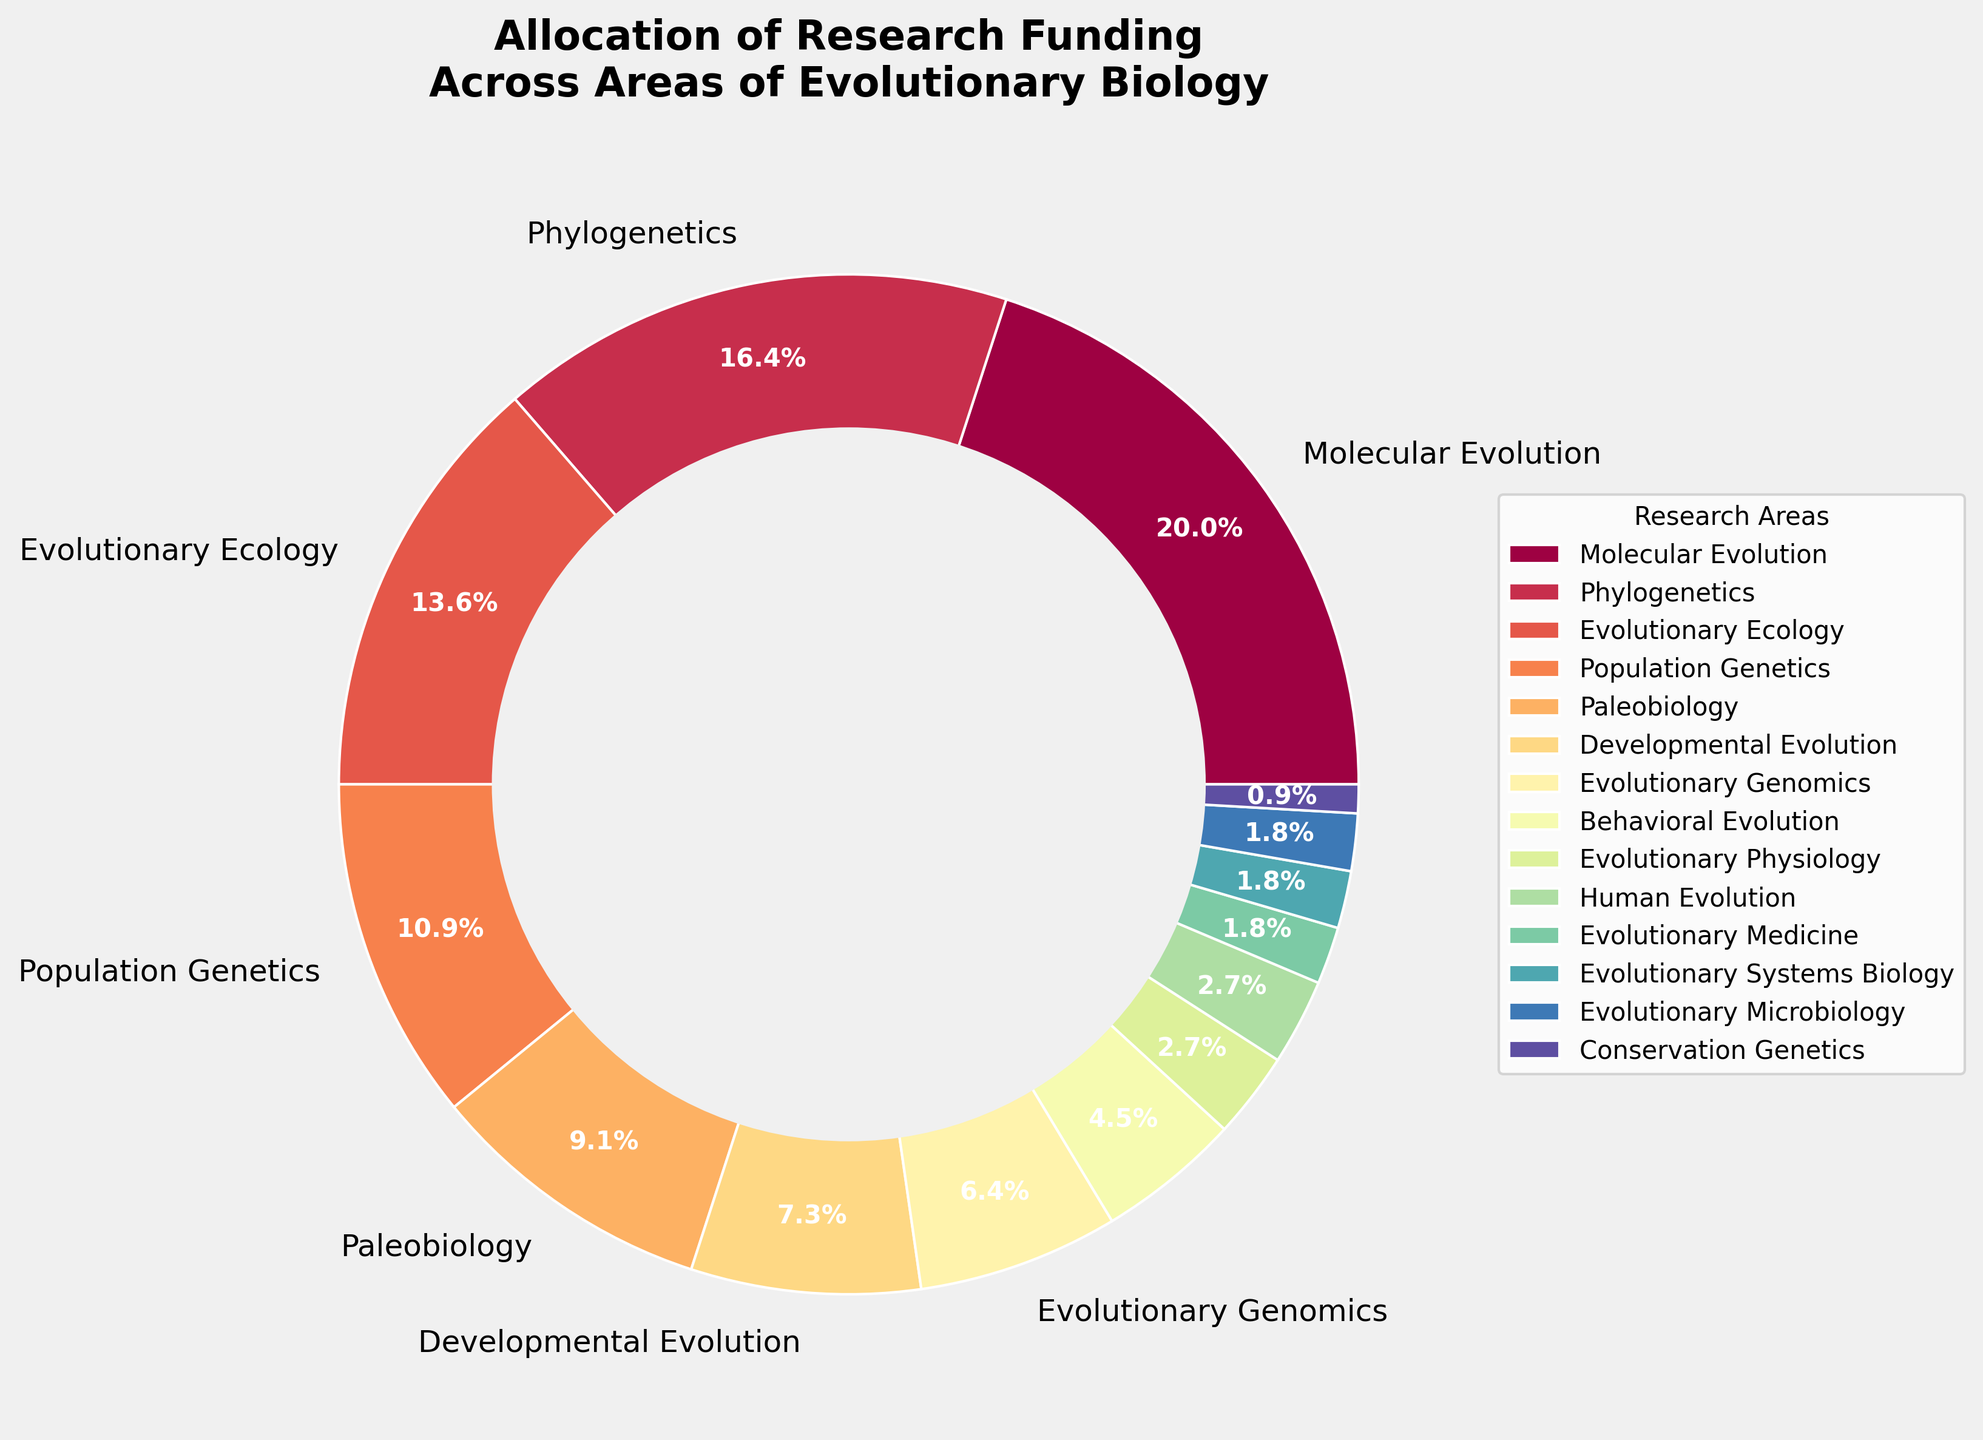What percentage of the total research funding is allocated to areas with less than 5% each? Sum the percentages of Evolutionary Physiology (3%), Human Evolution (3%), Evolutionary Medicine (2%), Evolutionary Systems Biology (2%), Evolutionary Microbiology (2%), and Conservation Genetics (1%). 3 + 3 + 2 + 2 + 2 + 1 = 13
Answer: 13% Which area receives the most funding? Look at the area with the largest percentage slice in the pie chart. Molecular Evolution has the largest slice at 22%
Answer: Molecular Evolution How much less funding does Population Genetics receive compared to Molecular Evolution? Subtract the funding percentage of Population Genetics (12%) from that of Molecular Evolution (22%). 22 - 12 = 10
Answer: 10% Do the combined funding percentages of Evolutionary Ecology and Developmental Evolution exceed that of Phylogenetics? Sum the funding percentages of Evolutionary Ecology (15%) and Developmental Evolution (8%), then compare with Phylogenetics (18%). 15 + 8 = 23, which is greater than 18
Answer: Yes Which areas are represented by the smallest slices in the pie chart? Look at areas with 2% or less funding. Evolutionary Medicine, Evolutionary Systems Biology, Evolutionary Microbiology, and Conservation Genetics all have 2% or less
Answer: Evolutionary Medicine, Evolutionary Systems Biology, Evolutionary Microbiology, Conservation Genetics How many areas receive more than 10% of the total funding? Identify areas that have more than 10% funding each: Molecular Evolution (22%), Phylogenetics (18%), Evolutionary Ecology (15%), and Population Genetics (12%). Count these areas.
Answer: 4 Is the funding for Behavioral Evolution more than Evolutionary Genomics? Compare the funding percentages of Behavioral Evolution (5%) and Evolutionary Genomics (7%). 5 is less than 7
Answer: No List the research areas with funding between 5% and 10%. Identify areas with funding percentages greater than 5% but less than 10%. Developmental Evolution (8%) and Evolutionary Genomics (7%) meet this criterion
Answer: Developmental Evolution, Evolutionary Genomics What is the difference in funding between the highest and lowest funded areas? The highest funded area is Molecular Evolution (22%), and the lowest funded area is Conservation Genetics (1%). Subtract the smallest percentage from the largest. 22 - 1 = 21
Answer: 21% What fraction of the pie chart is taken up by Phylogenetics and Evolutionary Ecology combined? Sum the funding percentages of Phylogenetics (18%) and Evolutionary Ecology (15%). 18 + 15 = 33%. Express 33% as a fraction of 100%. 33/100 = 33/100 = 0.33, therefore the fraction is 33/100
Answer: 33/100 